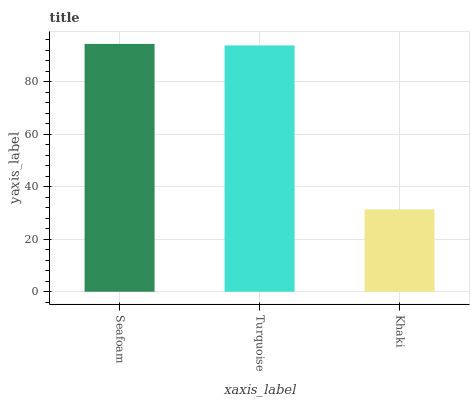Is Khaki the minimum?
Answer yes or no. Yes. Is Seafoam the maximum?
Answer yes or no. Yes. Is Turquoise the minimum?
Answer yes or no. No. Is Turquoise the maximum?
Answer yes or no. No. Is Seafoam greater than Turquoise?
Answer yes or no. Yes. Is Turquoise less than Seafoam?
Answer yes or no. Yes. Is Turquoise greater than Seafoam?
Answer yes or no. No. Is Seafoam less than Turquoise?
Answer yes or no. No. Is Turquoise the high median?
Answer yes or no. Yes. Is Turquoise the low median?
Answer yes or no. Yes. Is Khaki the high median?
Answer yes or no. No. Is Khaki the low median?
Answer yes or no. No. 